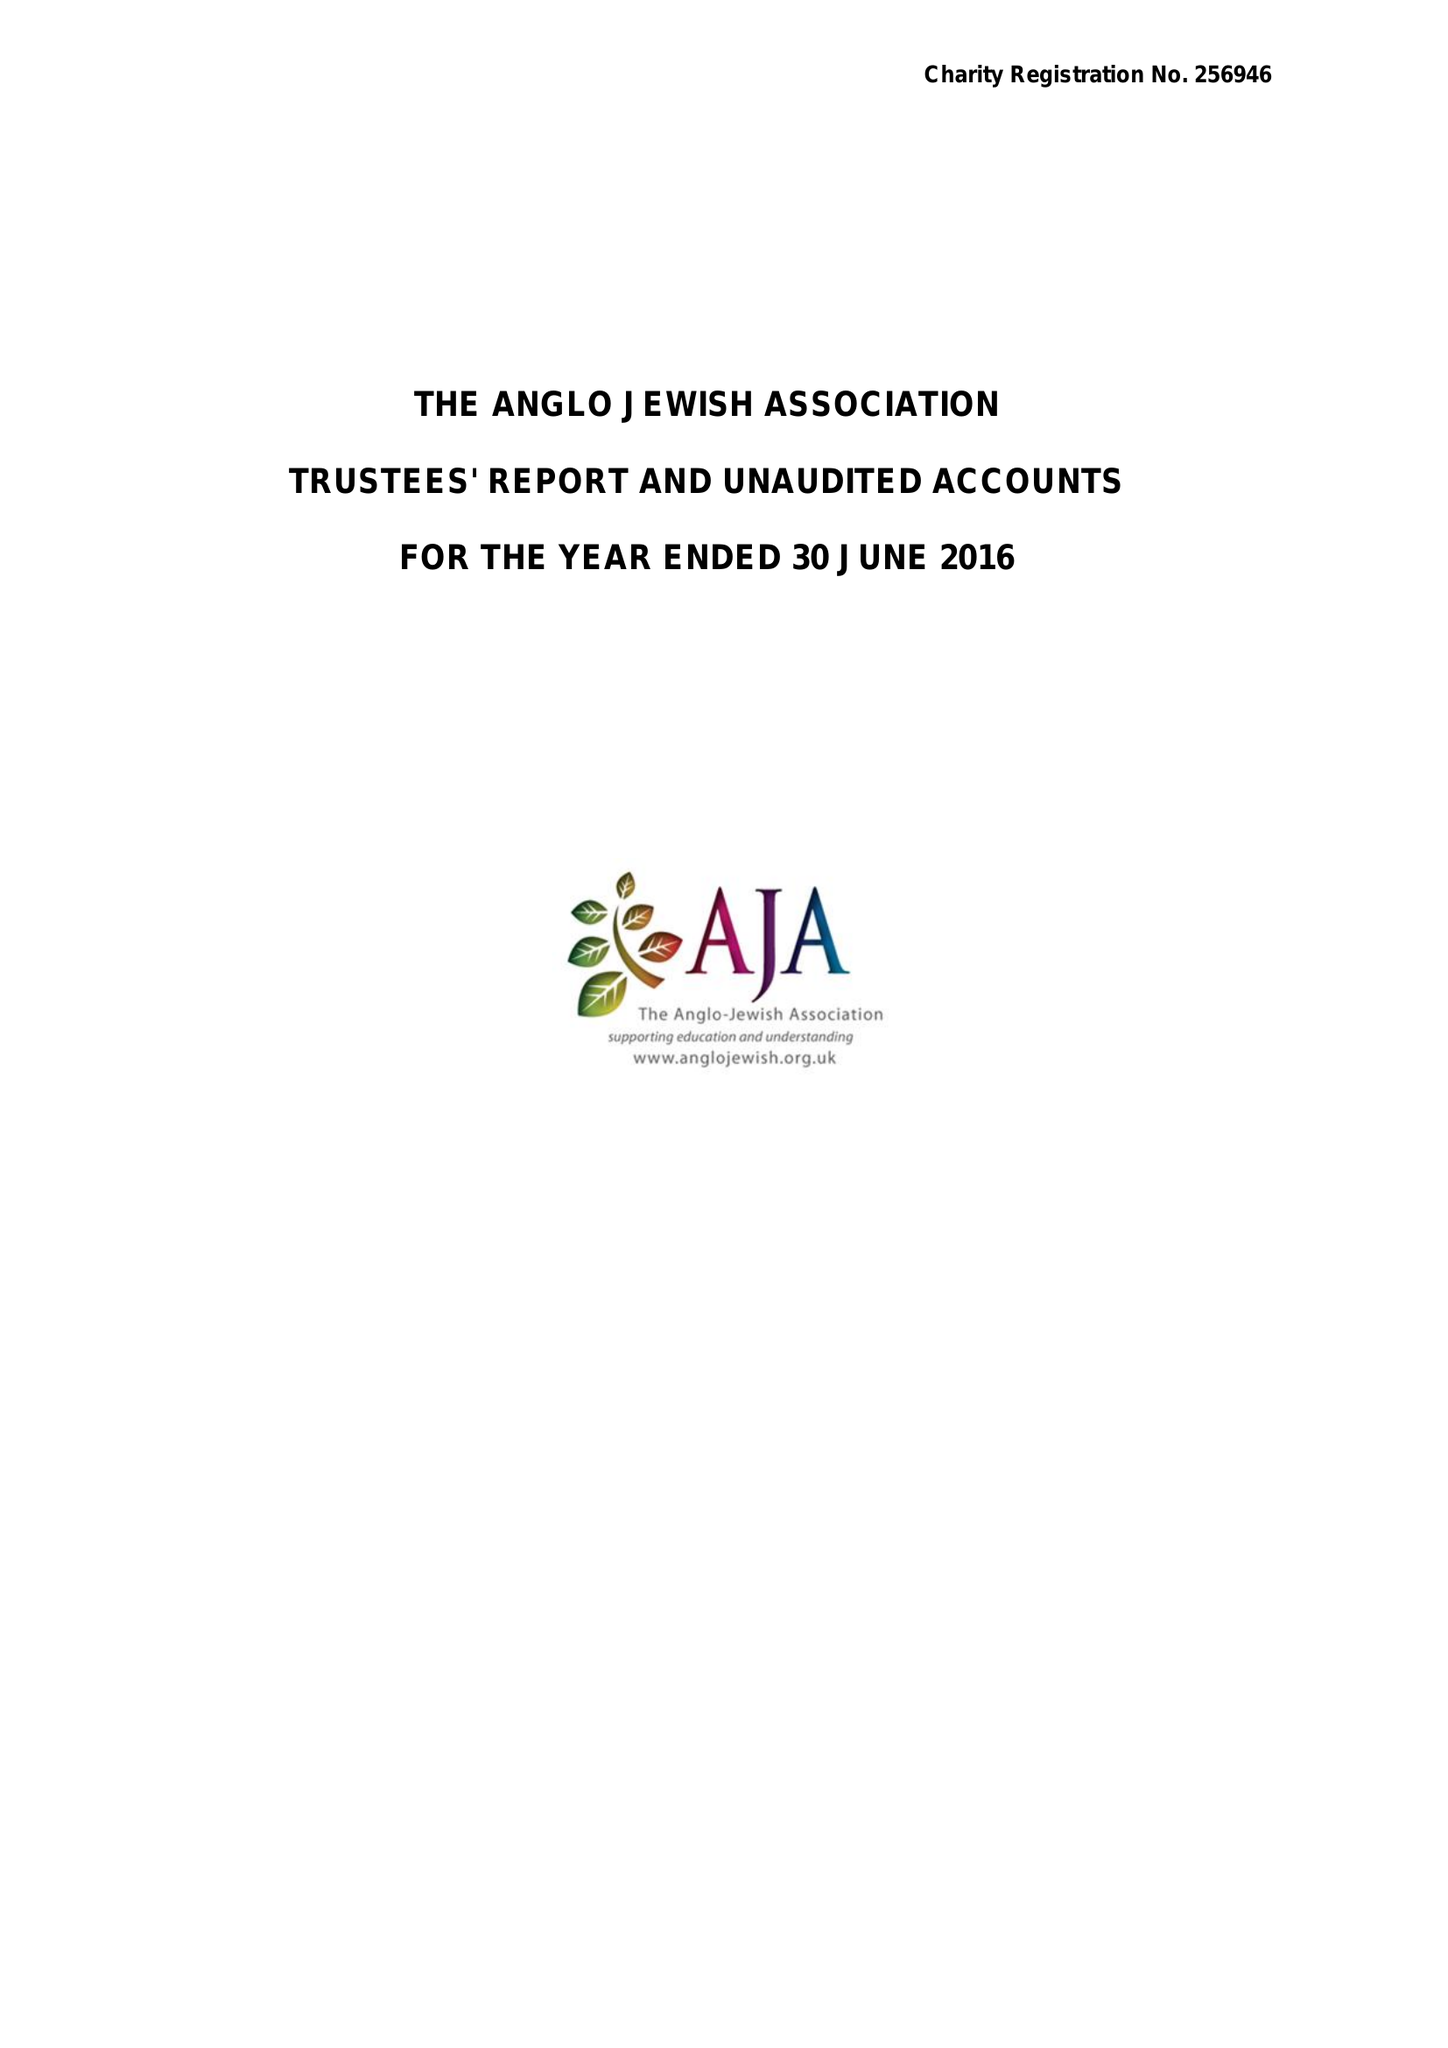What is the value for the charity_name?
Answer the question using a single word or phrase. The Anglo Jewish Association 